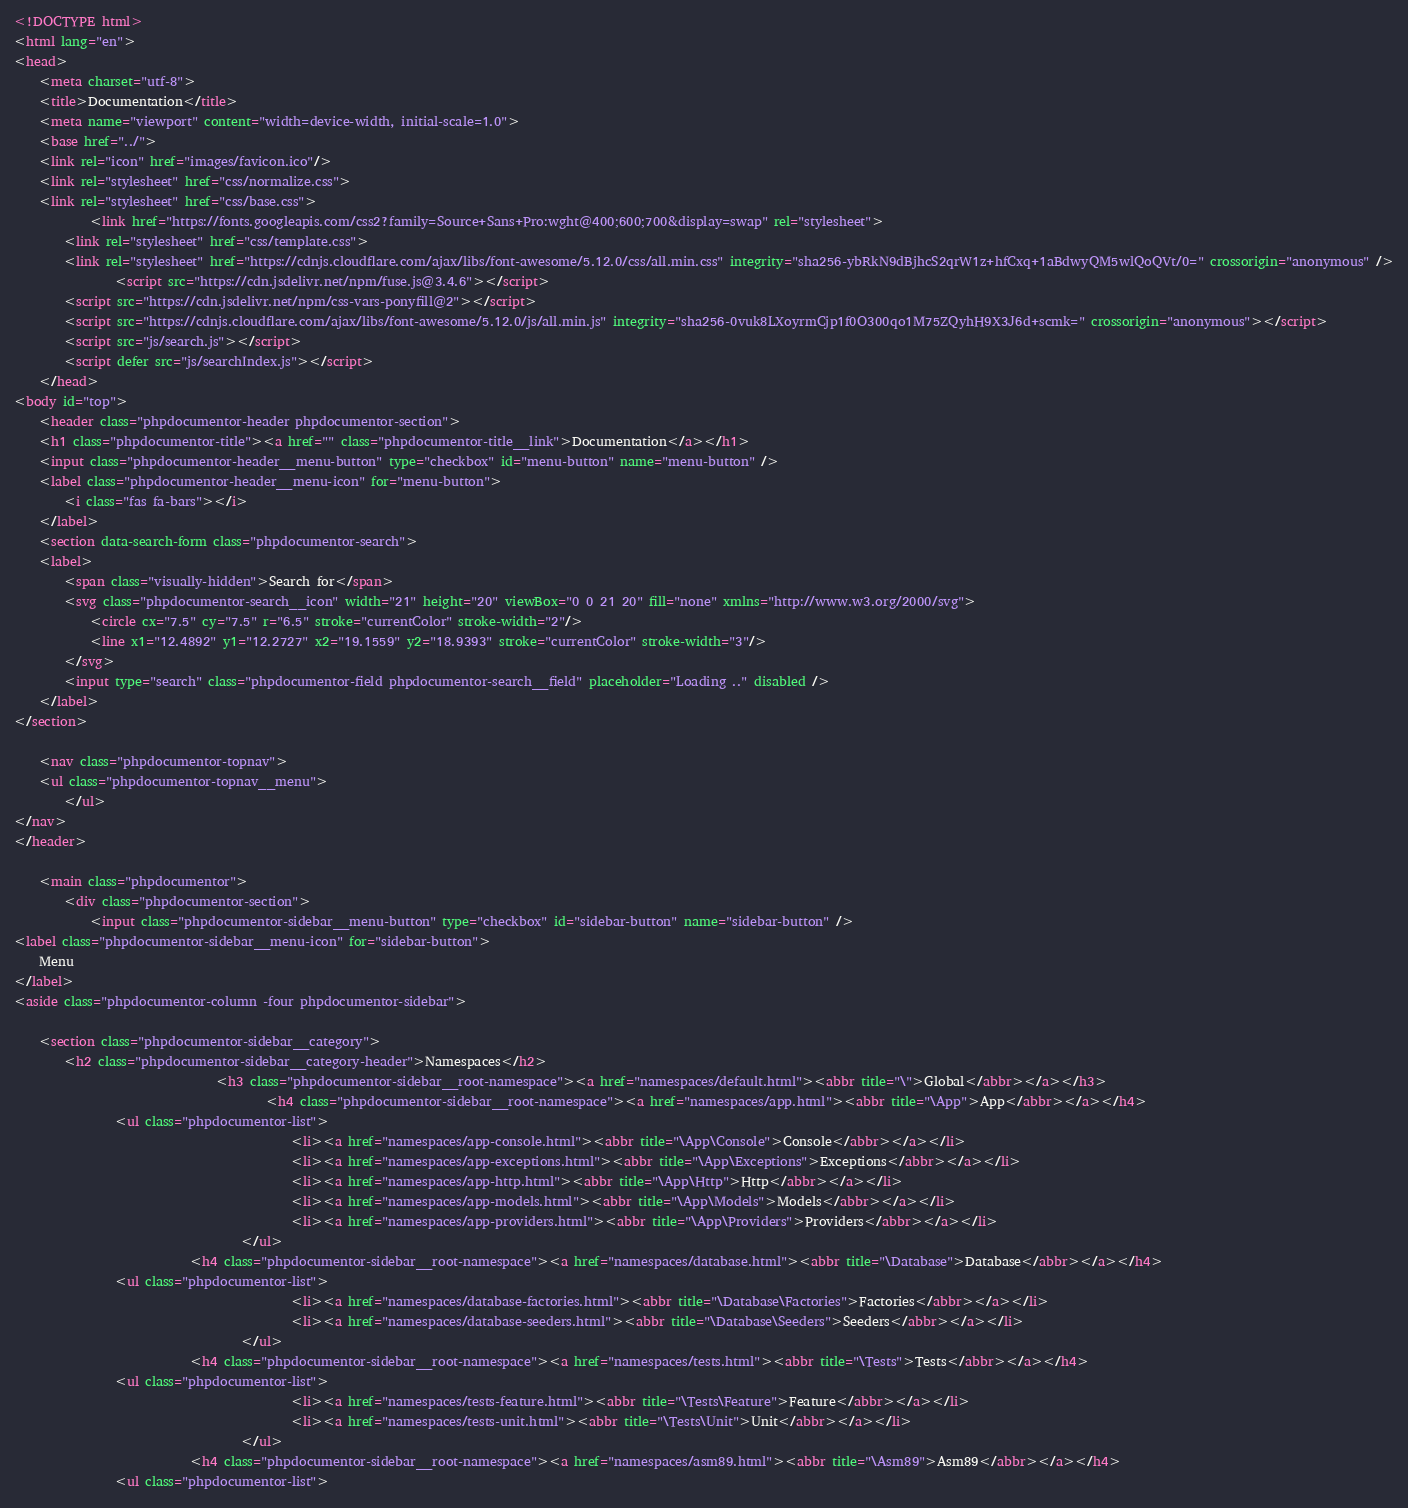Convert code to text. <code><loc_0><loc_0><loc_500><loc_500><_HTML_><!DOCTYPE html>
<html lang="en">
<head>
    <meta charset="utf-8">
    <title>Documentation</title>
    <meta name="viewport" content="width=device-width, initial-scale=1.0">
    <base href="../">
    <link rel="icon" href="images/favicon.ico"/>
    <link rel="stylesheet" href="css/normalize.css">
    <link rel="stylesheet" href="css/base.css">
            <link href="https://fonts.googleapis.com/css2?family=Source+Sans+Pro:wght@400;600;700&display=swap" rel="stylesheet">
        <link rel="stylesheet" href="css/template.css">
        <link rel="stylesheet" href="https://cdnjs.cloudflare.com/ajax/libs/font-awesome/5.12.0/css/all.min.css" integrity="sha256-ybRkN9dBjhcS2qrW1z+hfCxq+1aBdwyQM5wlQoQVt/0=" crossorigin="anonymous" />
                <script src="https://cdn.jsdelivr.net/npm/fuse.js@3.4.6"></script>
        <script src="https://cdn.jsdelivr.net/npm/css-vars-ponyfill@2"></script>
        <script src="https://cdnjs.cloudflare.com/ajax/libs/font-awesome/5.12.0/js/all.min.js" integrity="sha256-0vuk8LXoyrmCjp1f0O300qo1M75ZQyhH9X3J6d+scmk=" crossorigin="anonymous"></script>
        <script src="js/search.js"></script>
        <script defer src="js/searchIndex.js"></script>
    </head>
<body id="top">
    <header class="phpdocumentor-header phpdocumentor-section">
    <h1 class="phpdocumentor-title"><a href="" class="phpdocumentor-title__link">Documentation</a></h1>
    <input class="phpdocumentor-header__menu-button" type="checkbox" id="menu-button" name="menu-button" />
    <label class="phpdocumentor-header__menu-icon" for="menu-button">
        <i class="fas fa-bars"></i>
    </label>
    <section data-search-form class="phpdocumentor-search">
    <label>
        <span class="visually-hidden">Search for</span>
        <svg class="phpdocumentor-search__icon" width="21" height="20" viewBox="0 0 21 20" fill="none" xmlns="http://www.w3.org/2000/svg">
            <circle cx="7.5" cy="7.5" r="6.5" stroke="currentColor" stroke-width="2"/>
            <line x1="12.4892" y1="12.2727" x2="19.1559" y2="18.9393" stroke="currentColor" stroke-width="3"/>
        </svg>
        <input type="search" class="phpdocumentor-field phpdocumentor-search__field" placeholder="Loading .." disabled />
    </label>
</section>

    <nav class="phpdocumentor-topnav">
    <ul class="phpdocumentor-topnav__menu">
        </ul>
</nav>
</header>

    <main class="phpdocumentor">
        <div class="phpdocumentor-section">
            <input class="phpdocumentor-sidebar__menu-button" type="checkbox" id="sidebar-button" name="sidebar-button" />
<label class="phpdocumentor-sidebar__menu-icon" for="sidebar-button">
    Menu
</label>
<aside class="phpdocumentor-column -four phpdocumentor-sidebar">
    
    <section class="phpdocumentor-sidebar__category">
        <h2 class="phpdocumentor-sidebar__category-header">Namespaces</h2>
                                <h3 class="phpdocumentor-sidebar__root-namespace"><a href="namespaces/default.html"><abbr title="\">Global</abbr></a></h3>
                                        <h4 class="phpdocumentor-sidebar__root-namespace"><a href="namespaces/app.html"><abbr title="\App">App</abbr></a></h4>
                <ul class="phpdocumentor-list">
                                            <li><a href="namespaces/app-console.html"><abbr title="\App\Console">Console</abbr></a></li>
                                            <li><a href="namespaces/app-exceptions.html"><abbr title="\App\Exceptions">Exceptions</abbr></a></li>
                                            <li><a href="namespaces/app-http.html"><abbr title="\App\Http">Http</abbr></a></li>
                                            <li><a href="namespaces/app-models.html"><abbr title="\App\Models">Models</abbr></a></li>
                                            <li><a href="namespaces/app-providers.html"><abbr title="\App\Providers">Providers</abbr></a></li>
                                    </ul>
                            <h4 class="phpdocumentor-sidebar__root-namespace"><a href="namespaces/database.html"><abbr title="\Database">Database</abbr></a></h4>
                <ul class="phpdocumentor-list">
                                            <li><a href="namespaces/database-factories.html"><abbr title="\Database\Factories">Factories</abbr></a></li>
                                            <li><a href="namespaces/database-seeders.html"><abbr title="\Database\Seeders">Seeders</abbr></a></li>
                                    </ul>
                            <h4 class="phpdocumentor-sidebar__root-namespace"><a href="namespaces/tests.html"><abbr title="\Tests">Tests</abbr></a></h4>
                <ul class="phpdocumentor-list">
                                            <li><a href="namespaces/tests-feature.html"><abbr title="\Tests\Feature">Feature</abbr></a></li>
                                            <li><a href="namespaces/tests-unit.html"><abbr title="\Tests\Unit">Unit</abbr></a></li>
                                    </ul>
                            <h4 class="phpdocumentor-sidebar__root-namespace"><a href="namespaces/asm89.html"><abbr title="\Asm89">Asm89</abbr></a></h4>
                <ul class="phpdocumentor-list"></code> 